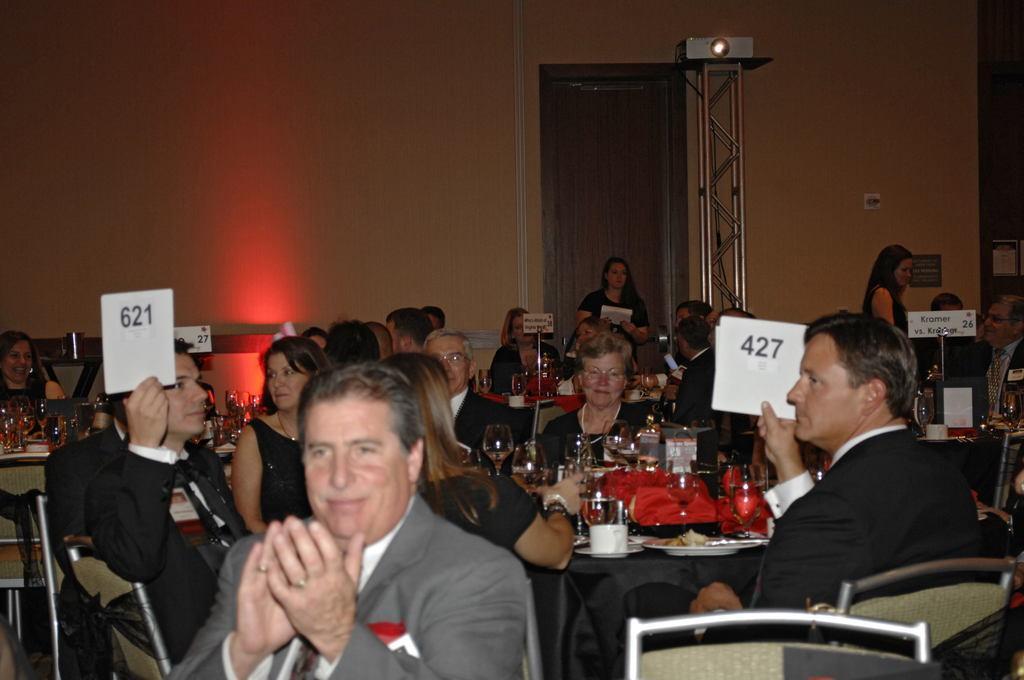Describe this image in one or two sentences. Here we can see a group of persons are sitting on the chair, and in front here is the table and glasses and some objects on it, and here is the wall. 